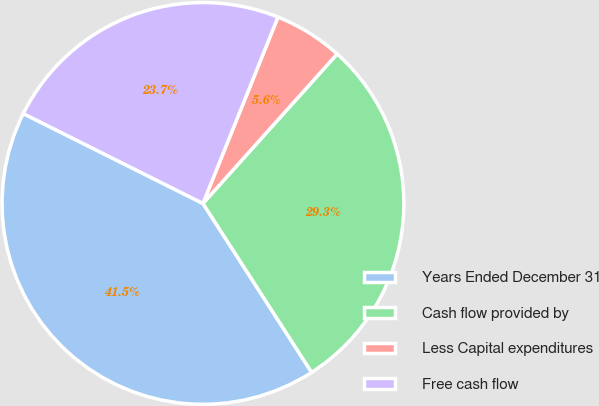Convert chart to OTSL. <chart><loc_0><loc_0><loc_500><loc_500><pie_chart><fcel>Years Ended December 31<fcel>Cash flow provided by<fcel>Less Capital expenditures<fcel>Free cash flow<nl><fcel>41.48%<fcel>29.26%<fcel>5.55%<fcel>23.71%<nl></chart> 